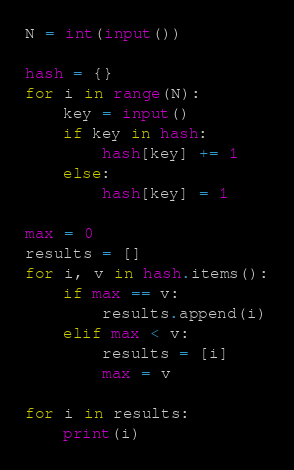<code> <loc_0><loc_0><loc_500><loc_500><_Python_>N = int(input())

hash = {}
for i in range(N):
	key = input()
	if key in hash:
		hash[key] += 1
	else:
		hash[key] = 1
        
max = 0
results = []
for i, v in hash.items():
	if max == v:
		results.append(i)
	elif max < v:
		results = [i]
		max = v
        
for i in results:
	print(i)
</code> 